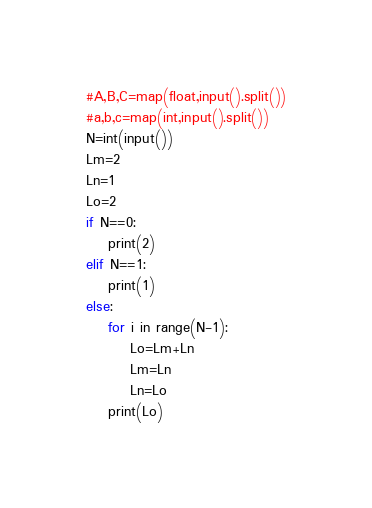<code> <loc_0><loc_0><loc_500><loc_500><_Python_>#A,B,C=map(float,input().split())
#a,b,c=map(int,input().split())
N=int(input())
Lm=2
Ln=1
Lo=2
if N==0:
	print(2)
elif N==1:
	print(1)
else:
	for i in range(N-1):
		Lo=Lm+Ln
		Lm=Ln
		Ln=Lo
	print(Lo)
</code> 